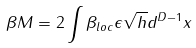<formula> <loc_0><loc_0><loc_500><loc_500>\beta M = 2 \int \beta _ { l o c } \epsilon \sqrt { h } d ^ { D - 1 } x</formula> 